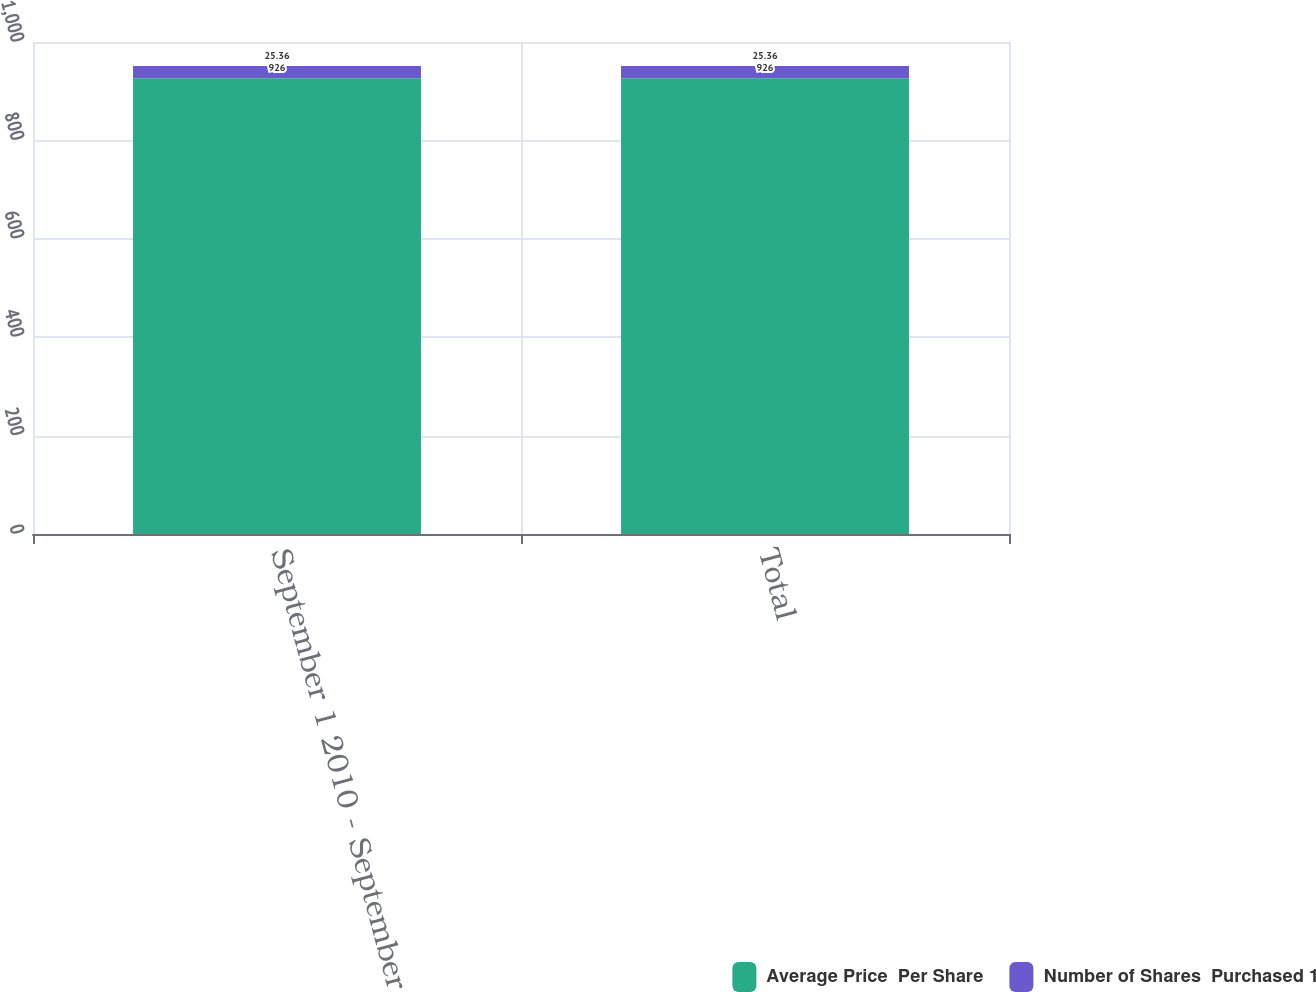Convert chart to OTSL. <chart><loc_0><loc_0><loc_500><loc_500><stacked_bar_chart><ecel><fcel>September 1 2010 - September<fcel>Total<nl><fcel>Average Price  Per Share<fcel>926<fcel>926<nl><fcel>Number of Shares  Purchased 1<fcel>25.36<fcel>25.36<nl></chart> 